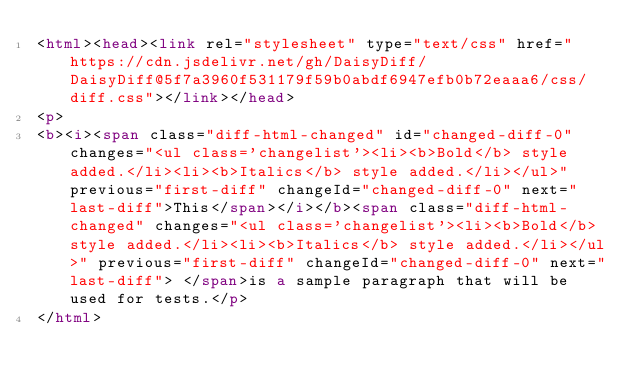Convert code to text. <code><loc_0><loc_0><loc_500><loc_500><_HTML_><html><head><link rel="stylesheet" type="text/css" href="https://cdn.jsdelivr.net/gh/DaisyDiff/DaisyDiff@5f7a3960f531179f59b0abdf6947efb0b72eaaa6/css/diff.css"></link></head>
<p>
<b><i><span class="diff-html-changed" id="changed-diff-0" changes="<ul class='changelist'><li><b>Bold</b> style added.</li><li><b>Italics</b> style added.</li></ul>" previous="first-diff" changeId="changed-diff-0" next="last-diff">This</span></i></b><span class="diff-html-changed" changes="<ul class='changelist'><li><b>Bold</b> style added.</li><li><b>Italics</b> style added.</li></ul>" previous="first-diff" changeId="changed-diff-0" next="last-diff"> </span>is a sample paragraph that will be used for tests.</p>
</html></code> 